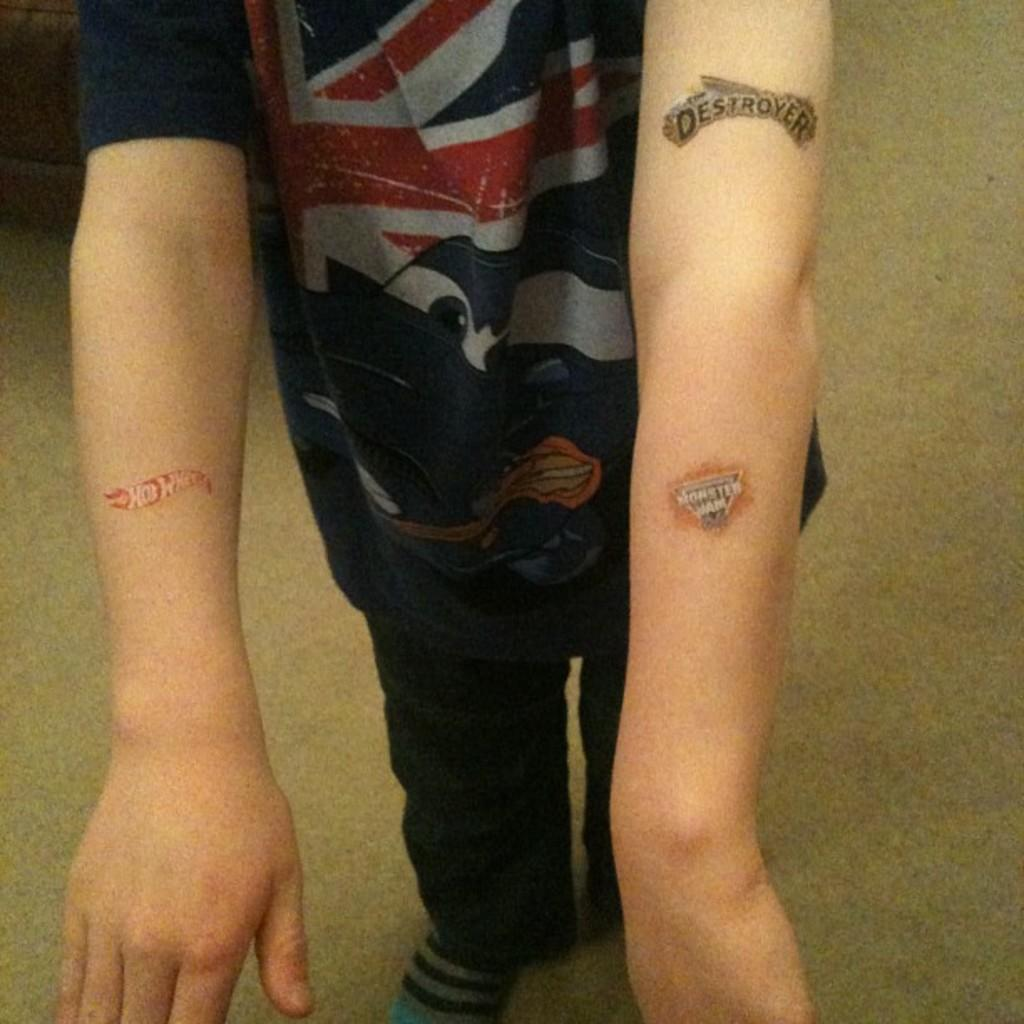Provide a one-sentence caption for the provided image. a boy with fake tattoos that say HOT WHEELS, DESTROYER and MONSTER JAM. 